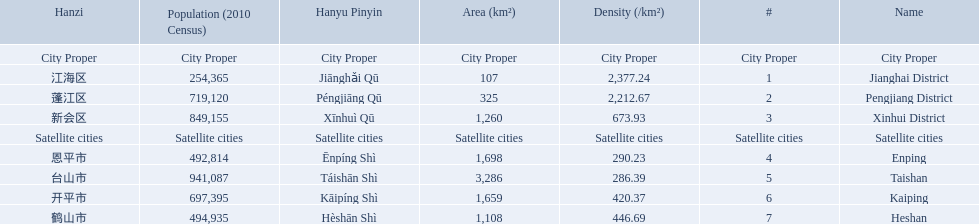What city propers are listed? Jianghai District, Pengjiang District, Xinhui District. Which hast he smallest area in km2? Jianghai District. 